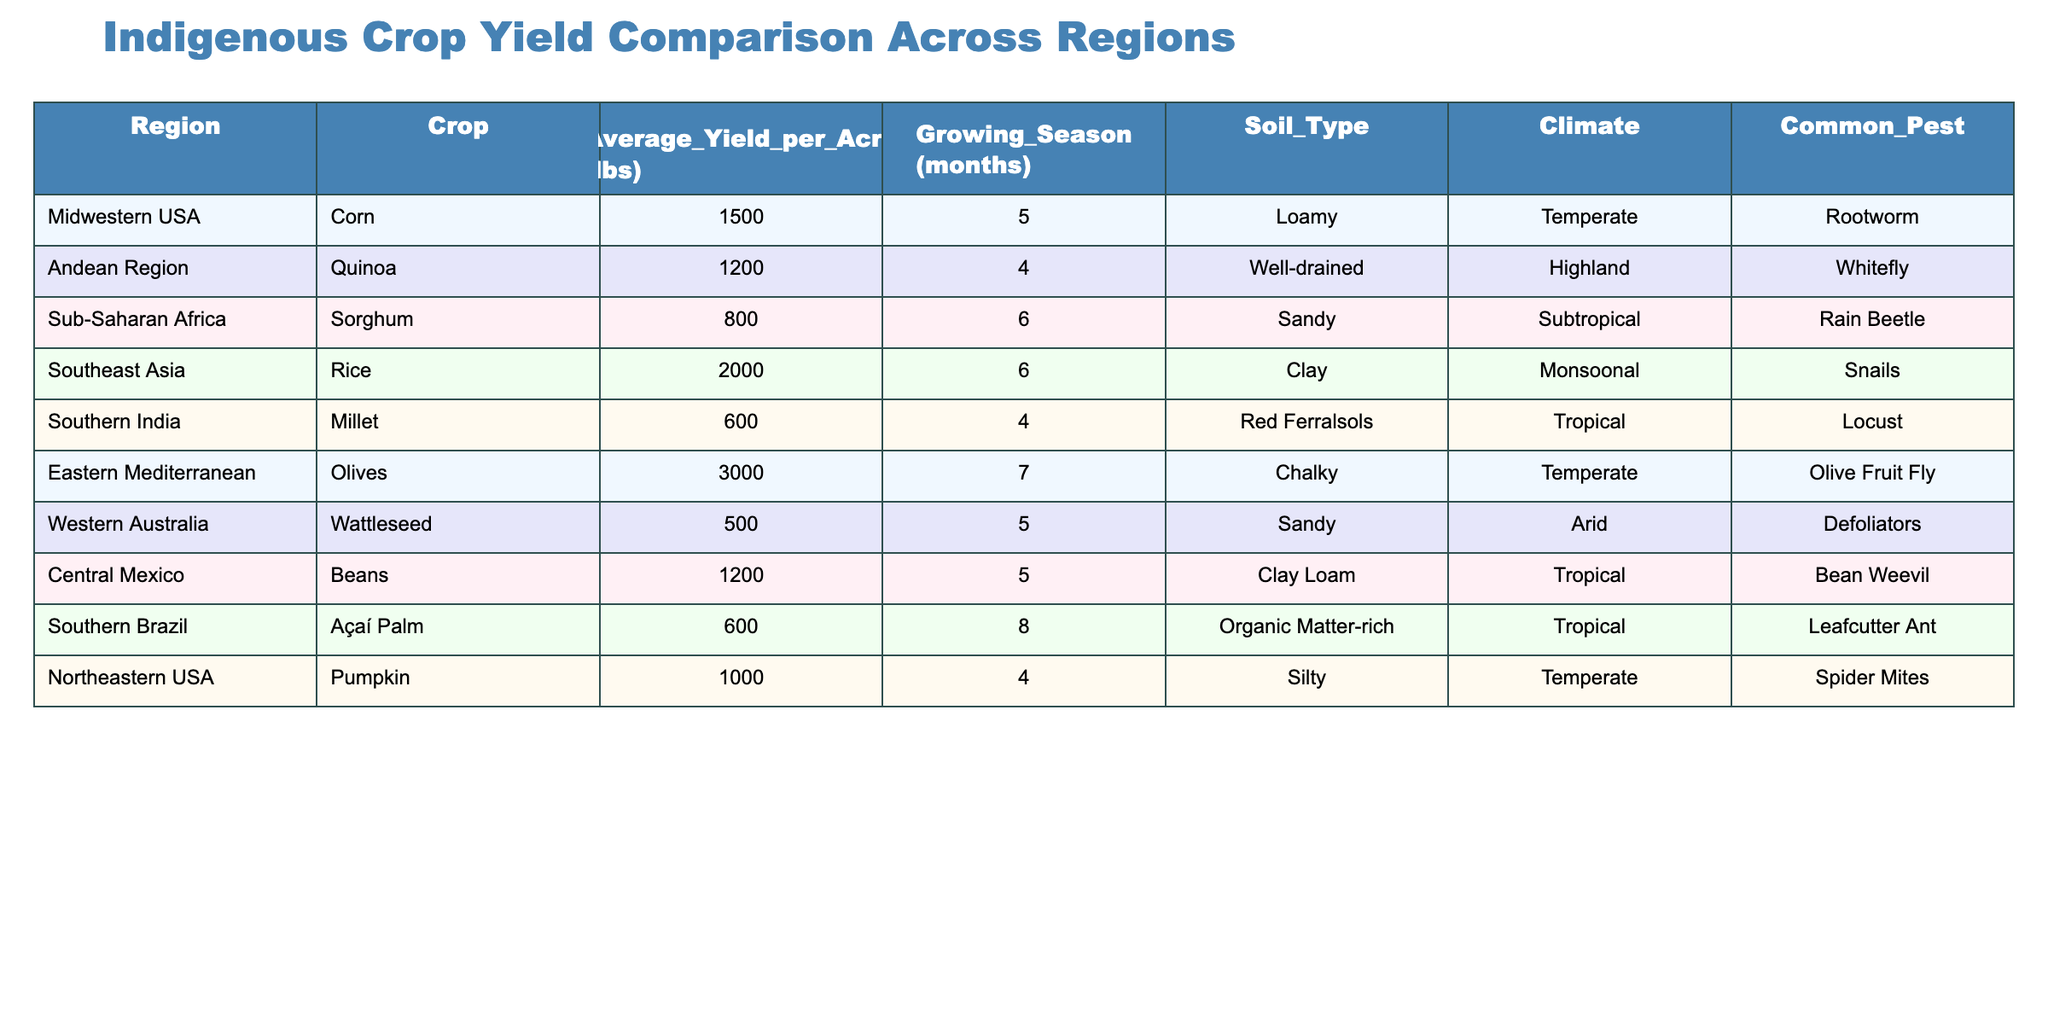What is the average yield per acre of quinoa in the Andean Region? In the table, under the 'Average_Yield_per_Acre (lbs)' column, the average yield for quinoa in the Andean Region is listed as 1200 lbs.
Answer: 1200 lbs Which region has the highest crop yield and what is the crop? The highest yield in the table is for olives from the Eastern Mediterranean, with an average yield of 3000 lbs per acre.
Answer: Eastern Mediterranean, Olives How many months is the growing season for rice in Southeast Asia? The growing season for rice in Southeast Asia is specified in the 'Growing_Season (months)' column, which states it is 6 months long.
Answer: 6 months Which indigenous crop has the lowest yield per acre? Açaí Palm from Southern Brazil shows the lowest yield per acre at 600 lbs, and this is visible in the 'Average_Yield_per_Acre (lbs)' column.
Answer: Açaí Palm, 600 lbs Is the average yield of sorghum greater than 1000 lbs per acre? The average yield for sorghum in Sub-Saharan Africa is 800 lbs, which is less than 1000 lbs, indicating that the statement is false.
Answer: No What is the difference in average yield between corn and millet? Corn has an average yield of 1500 lbs and millet has an average yield of 600 lbs. The difference is therefore 1500 - 600 = 900 lbs.
Answer: 900 lbs Which crop has a growing season longer than 6 months? In the table, the crops listed are examined; only olives from the Eastern Mediterranean have a growing season of 7 months, which is longer than 6 months.
Answer: Olives, 7 months How do the average yields of beans and quinoa compare? Beans have an average yield of 1200 lbs while quinoa has 1200 lbs as well. Both have the same yield, indicating they are equivalent.
Answer: They are equivalent, both 1200 lbs Are there crops from tropical regions that have yields greater than 600 lbs? From the table, rice (2000 lbs) and beans (1200 lbs) are both from tropical regions and exceed 600 lbs in yield. Thus, the answer is yes.
Answer: Yes What is the total average yield of millet and açaí palm? The average yield of millet is 600 lbs and that of açaí palm is also 600 lbs. Therefore, the total average yield is 600 + 600 = 1200 lbs.
Answer: 1200 lbs 